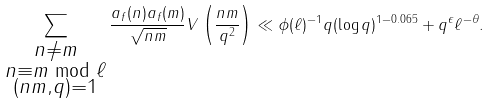Convert formula to latex. <formula><loc_0><loc_0><loc_500><loc_500>\sum _ { \substack { n \neq m \\ n \equiv m \bmod \ell \\ ( n m , q ) = 1 } } \frac { a _ { f } ( n ) a _ { f } ( m ) } { \sqrt { n m } } V \left ( \frac { n m } { q ^ { 2 } } \right ) \ll \phi ( \ell ) ^ { - 1 } q ( \log q ) ^ { 1 - 0 . 0 6 5 } + q ^ { \epsilon } \ell ^ { - \theta } .</formula> 